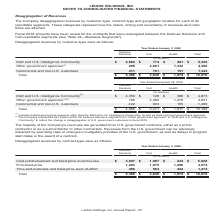According to Leidos Holdings's financial document, Where are the Company's majority revenues generated from? U.S. government contracts, either as a prime contractor or as a subcontractor to other contractors.. The document states: "ority of the Company's revenues are generated from U.S. government contracts, either as a prime contractor or as a subcontractor to other contractors...." Also, What was the Cost-reimbursement and fixed-price-incentive-fee in Defense Solutions, Civil and Health respectively? The document contains multiple relevant values: $3,697, $1,997, $234 (in millions). From the document: "bursement and fixed-price-incentive-fee $ 3,697 $ 1,997 $ 234 $ 5,928 Firm-fixed-price 1,203 1,075 1,296 3,574 Time-and-materials and fixed-price-leve..." Also, What was the total Firm-fixed-price? According to the financial document, 3,574 (in millions). The relevant text states: "$ 234 $ 5,928 Firm-fixed-price 1,203 1,075 1,296 3,574 Time-and-materials and fixed-price-level-of-effort 466 564 444 1,474 Total $ 5,366 $ 3,636 $ 1,974..." Additionally, In which category was Cost-reimbursement and fixed-price-incentive-fee more than 1,000 million? The document shows two values: Defense Solutions and Civil. Locate and analyze cost-reimbursement and fixed-price-incentive-fee in row 5. From the document: "Defense Solutions Civil Health Total Defense Solutions Civil Health Total..." Also, can you calculate: What was the difference in the Cost-reimbursement and fixed-price-incentive-fee between Civil and Health? Based on the calculation: 1,997 - 234, the result is 1763 (in millions). This is based on the information: "bursement and fixed-price-incentive-fee $ 3,697 $ 1,997 $ 234 $ 5,928 Firm-fixed-price 1,203 1,075 1,296 3,574 Time-and-materials and fixed-price-level-of- t and fixed-price-incentive-fee $ 3,697 $ 1,..." The key data points involved are: 1,997, 234. Also, can you calculate: What was the average Firm-fixed-price under Solutions, Civil and Health? To answer this question, I need to perform calculations using the financial data. The calculation is: (1,203 + 1,075 + 1,296) / 3, which equals 1191.33 (in millions). This is based on the information: "ee $ 3,697 $ 1,997 $ 234 $ 5,928 Firm-fixed-price 1,203 1,075 1,296 3,574 Time-and-materials and fixed-price-level-of-effort 466 564 444 1,474 Total $ 5,36 ,697 $ 1,997 $ 234 $ 5,928 Firm-fixed-price ..." The key data points involved are: 1,075, 1,203, 1,296. 